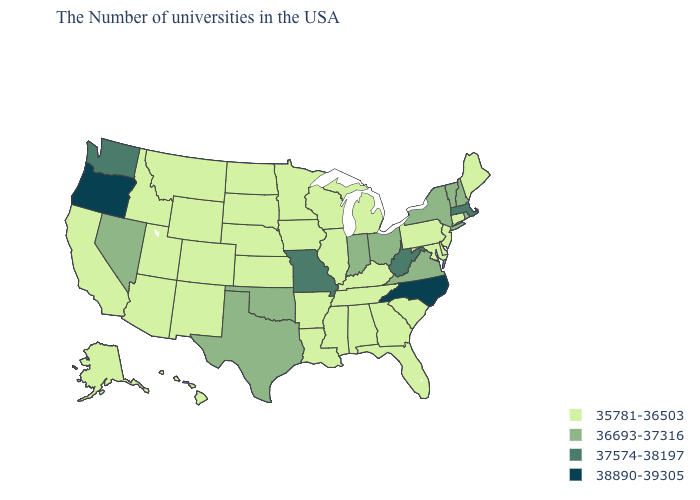Does Illinois have the highest value in the MidWest?
Be succinct. No. What is the value of Wyoming?
Keep it brief. 35781-36503. What is the lowest value in states that border Iowa?
Give a very brief answer. 35781-36503. Name the states that have a value in the range 36693-37316?
Keep it brief. Rhode Island, New Hampshire, Vermont, New York, Virginia, Ohio, Indiana, Oklahoma, Texas, Nevada. Name the states that have a value in the range 36693-37316?
Quick response, please. Rhode Island, New Hampshire, Vermont, New York, Virginia, Ohio, Indiana, Oklahoma, Texas, Nevada. Name the states that have a value in the range 36693-37316?
Be succinct. Rhode Island, New Hampshire, Vermont, New York, Virginia, Ohio, Indiana, Oklahoma, Texas, Nevada. Name the states that have a value in the range 37574-38197?
Concise answer only. Massachusetts, West Virginia, Missouri, Washington. What is the value of Idaho?
Be succinct. 35781-36503. Name the states that have a value in the range 38890-39305?
Short answer required. North Carolina, Oregon. Among the states that border North Carolina , does Georgia have the lowest value?
Concise answer only. Yes. Name the states that have a value in the range 36693-37316?
Give a very brief answer. Rhode Island, New Hampshire, Vermont, New York, Virginia, Ohio, Indiana, Oklahoma, Texas, Nevada. Which states hav the highest value in the South?
Answer briefly. North Carolina. What is the value of Iowa?
Quick response, please. 35781-36503. Name the states that have a value in the range 37574-38197?
Answer briefly. Massachusetts, West Virginia, Missouri, Washington. 